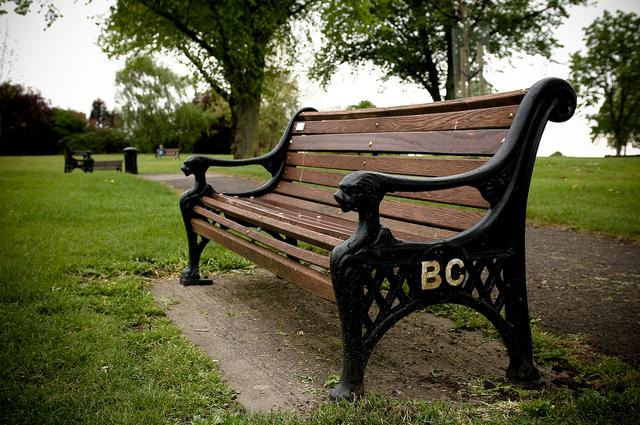What type of bench is this? park 